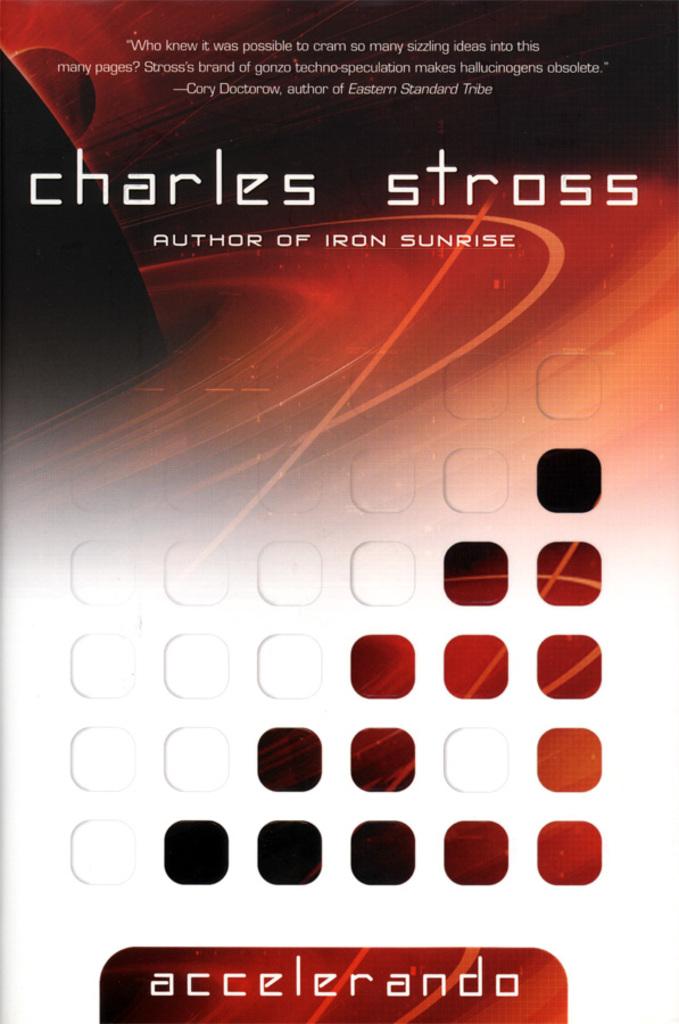Who is this fantastic author?
Provide a short and direct response. Charles stross. What is the book title?
Offer a terse response. Accelerando. 